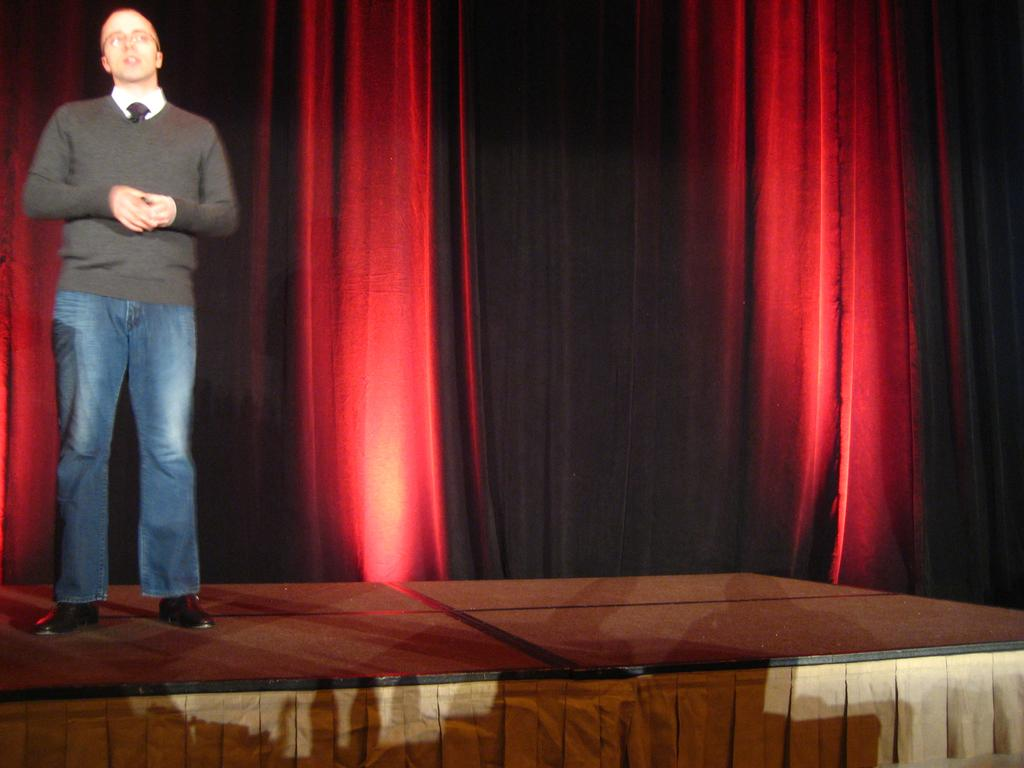What is the main subject of the image? The main subject of the image is a man standing on the stage. What can be seen in the background of the image? There are curtains in the background of the image. Where is the kettle located in the image? There is no kettle present in the image. What type of parent is observable in the image? There is no parent present in the image. 